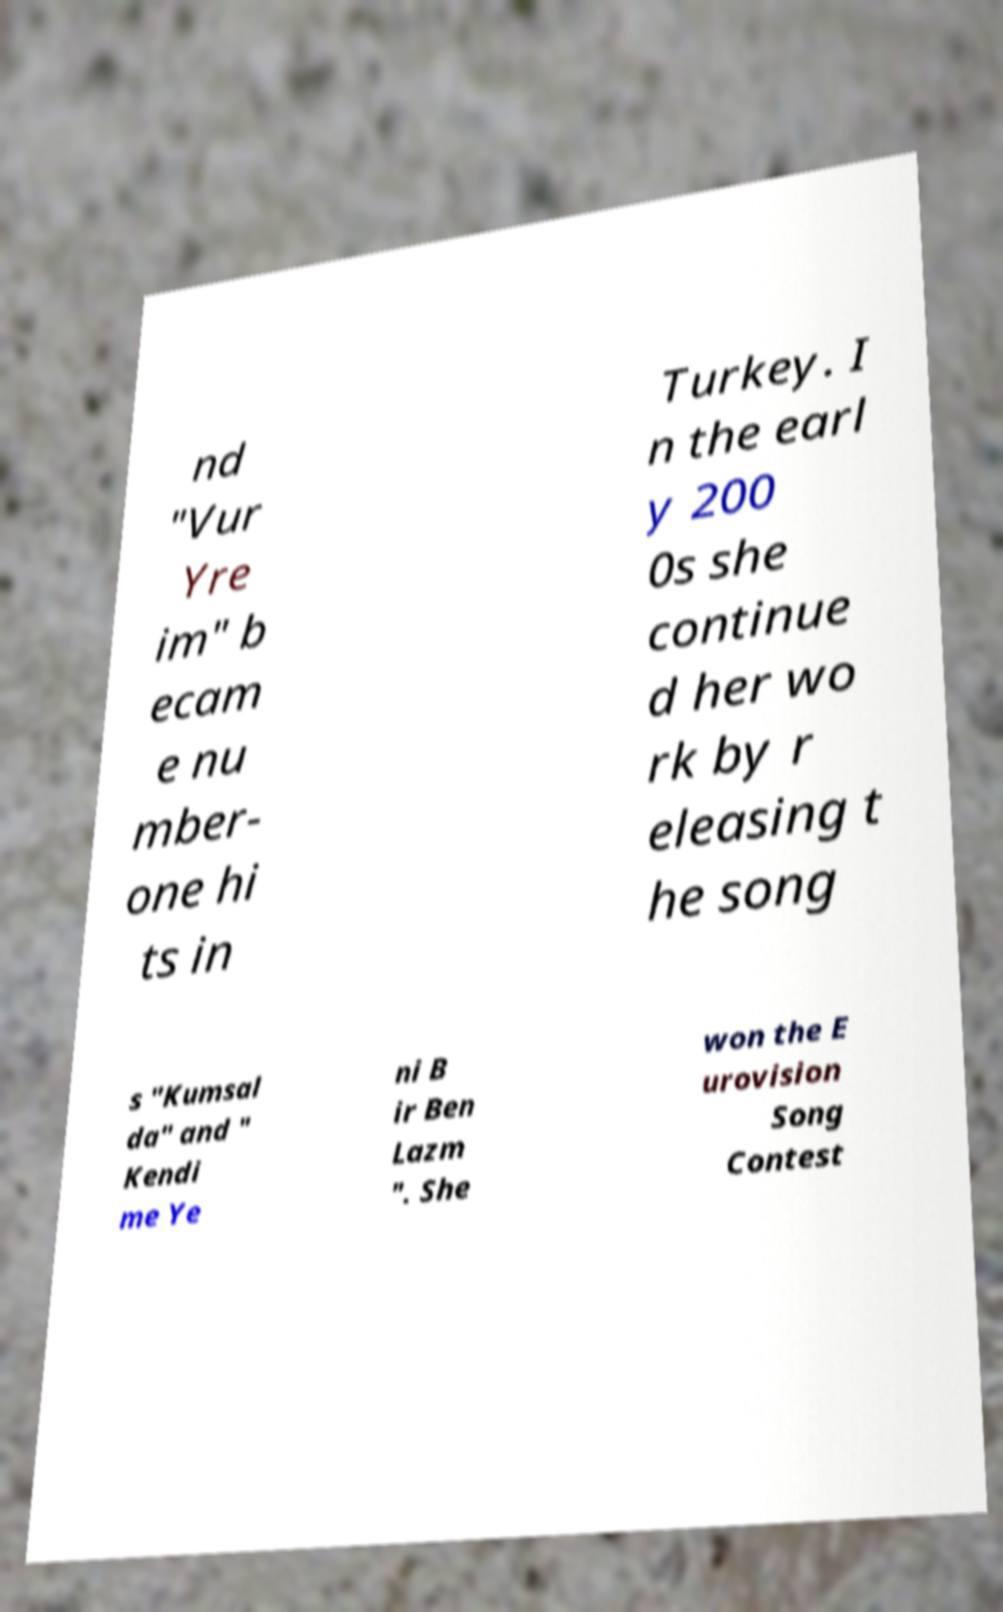I need the written content from this picture converted into text. Can you do that? nd "Vur Yre im" b ecam e nu mber- one hi ts in Turkey. I n the earl y 200 0s she continue d her wo rk by r eleasing t he song s "Kumsal da" and " Kendi me Ye ni B ir Ben Lazm ". She won the E urovision Song Contest 